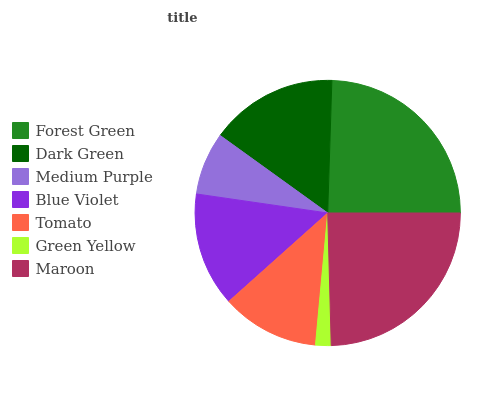Is Green Yellow the minimum?
Answer yes or no. Yes. Is Maroon the maximum?
Answer yes or no. Yes. Is Dark Green the minimum?
Answer yes or no. No. Is Dark Green the maximum?
Answer yes or no. No. Is Forest Green greater than Dark Green?
Answer yes or no. Yes. Is Dark Green less than Forest Green?
Answer yes or no. Yes. Is Dark Green greater than Forest Green?
Answer yes or no. No. Is Forest Green less than Dark Green?
Answer yes or no. No. Is Blue Violet the high median?
Answer yes or no. Yes. Is Blue Violet the low median?
Answer yes or no. Yes. Is Green Yellow the high median?
Answer yes or no. No. Is Forest Green the low median?
Answer yes or no. No. 